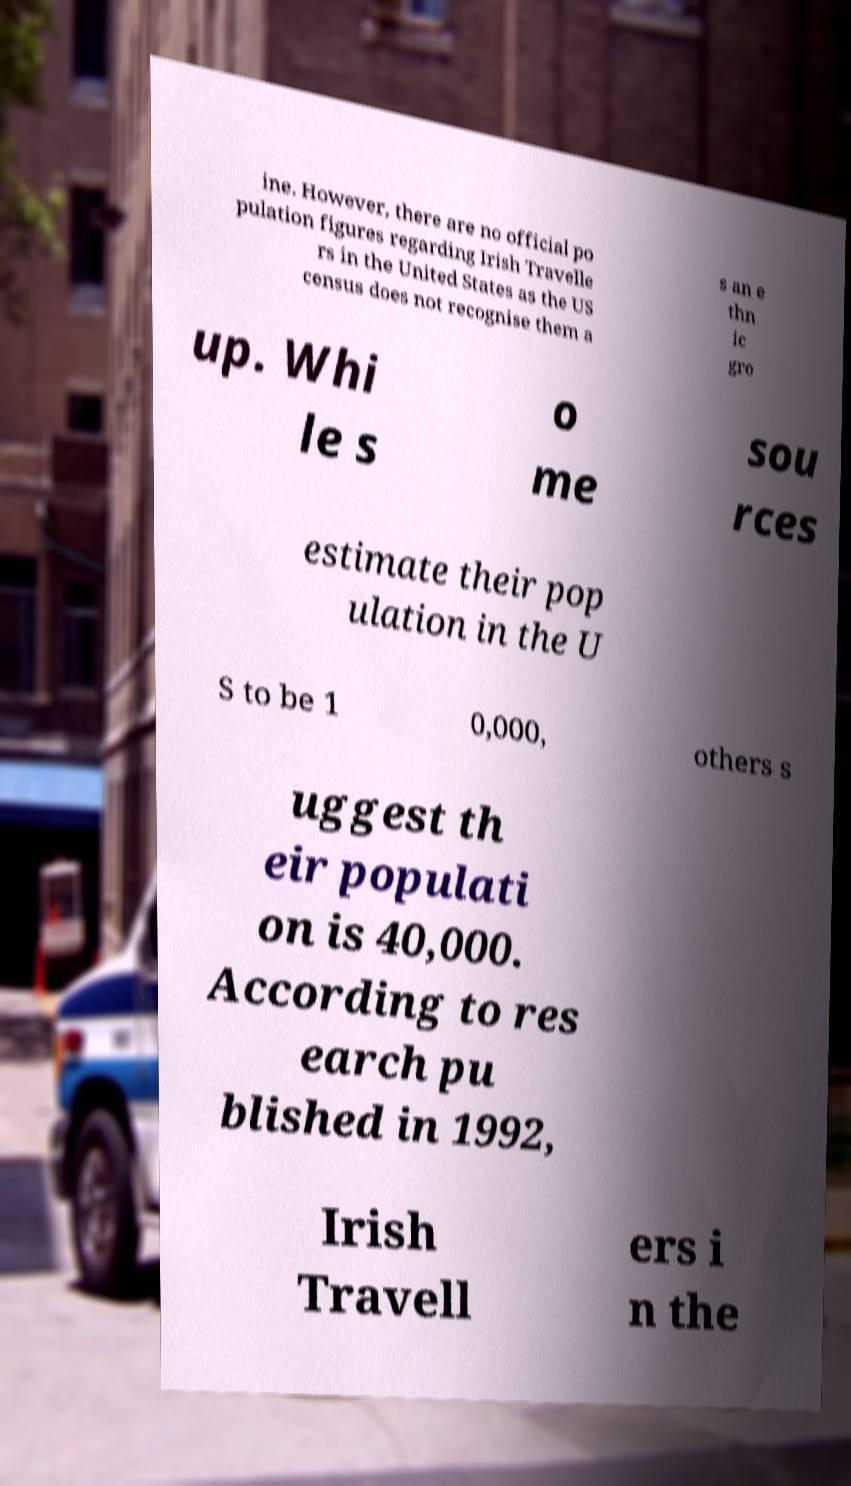What messages or text are displayed in this image? I need them in a readable, typed format. ine. However, there are no official po pulation figures regarding Irish Travelle rs in the United States as the US census does not recognise them a s an e thn ic gro up. Whi le s o me sou rces estimate their pop ulation in the U S to be 1 0,000, others s uggest th eir populati on is 40,000. According to res earch pu blished in 1992, Irish Travell ers i n the 